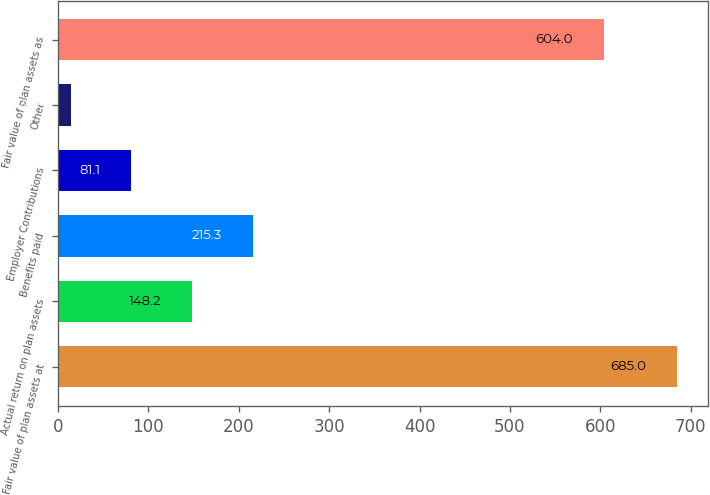<chart> <loc_0><loc_0><loc_500><loc_500><bar_chart><fcel>Fair value of plan assets at<fcel>Actual return on plan assets<fcel>Benefits paid<fcel>Employer Contributions<fcel>Other<fcel>Fair value of plan assets as<nl><fcel>685<fcel>148.2<fcel>215.3<fcel>81.1<fcel>14<fcel>604<nl></chart> 